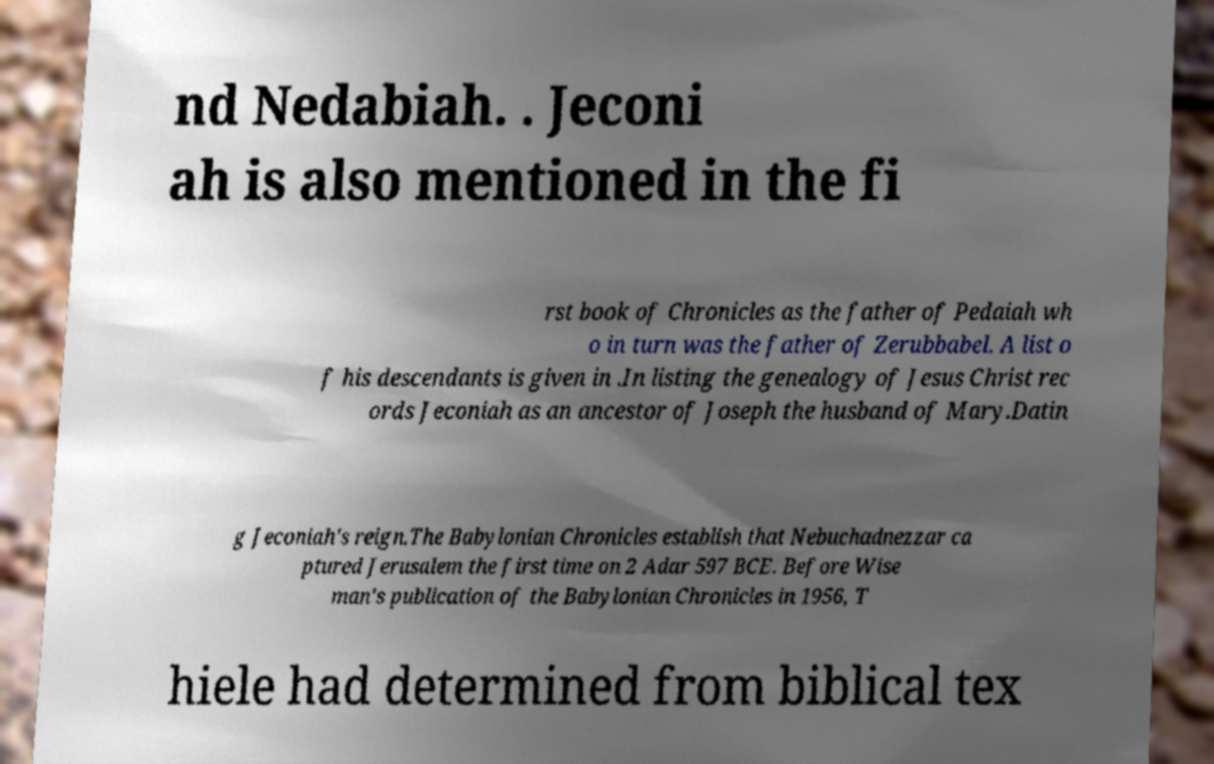Can you read and provide the text displayed in the image?This photo seems to have some interesting text. Can you extract and type it out for me? nd Nedabiah. . Jeconi ah is also mentioned in the fi rst book of Chronicles as the father of Pedaiah wh o in turn was the father of Zerubbabel. A list o f his descendants is given in .In listing the genealogy of Jesus Christ rec ords Jeconiah as an ancestor of Joseph the husband of Mary.Datin g Jeconiah's reign.The Babylonian Chronicles establish that Nebuchadnezzar ca ptured Jerusalem the first time on 2 Adar 597 BCE. Before Wise man's publication of the Babylonian Chronicles in 1956, T hiele had determined from biblical tex 